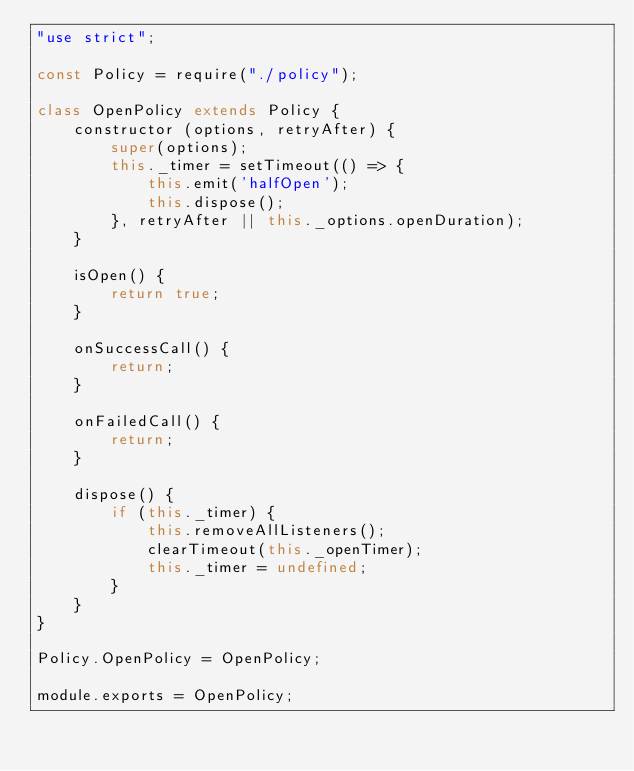Convert code to text. <code><loc_0><loc_0><loc_500><loc_500><_JavaScript_>"use strict";

const Policy = require("./policy");

class OpenPolicy extends Policy {
    constructor (options, retryAfter) {
        super(options);
        this._timer = setTimeout(() => {
            this.emit('halfOpen');
            this.dispose();
        }, retryAfter || this._options.openDuration);
    }

    isOpen() {
        return true;
    }

    onSuccessCall() {
        return;
    }

    onFailedCall() {
        return;
    }

    dispose() {
        if (this._timer) {
            this.removeAllListeners();
            clearTimeout(this._openTimer);
            this._timer = undefined;
        }
    }
}

Policy.OpenPolicy = OpenPolicy;

module.exports = OpenPolicy;
</code> 